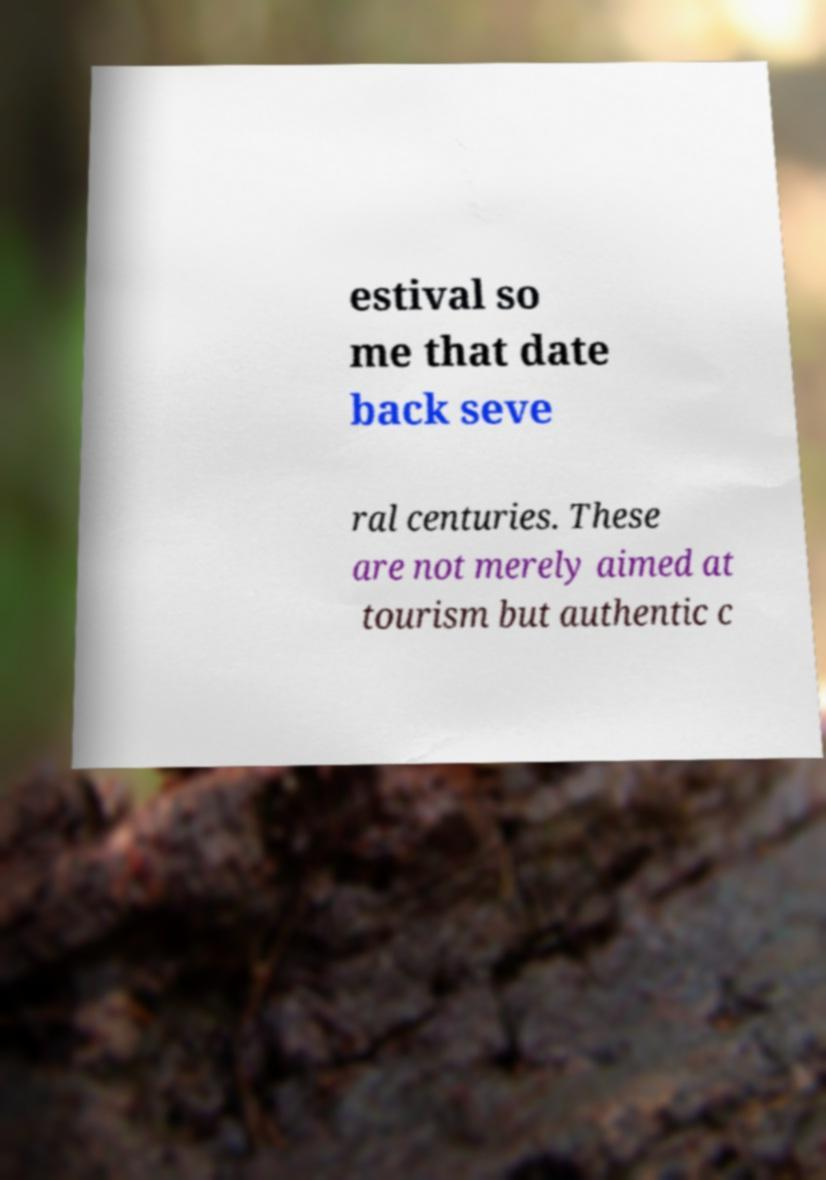Could you assist in decoding the text presented in this image and type it out clearly? estival so me that date back seve ral centuries. These are not merely aimed at tourism but authentic c 